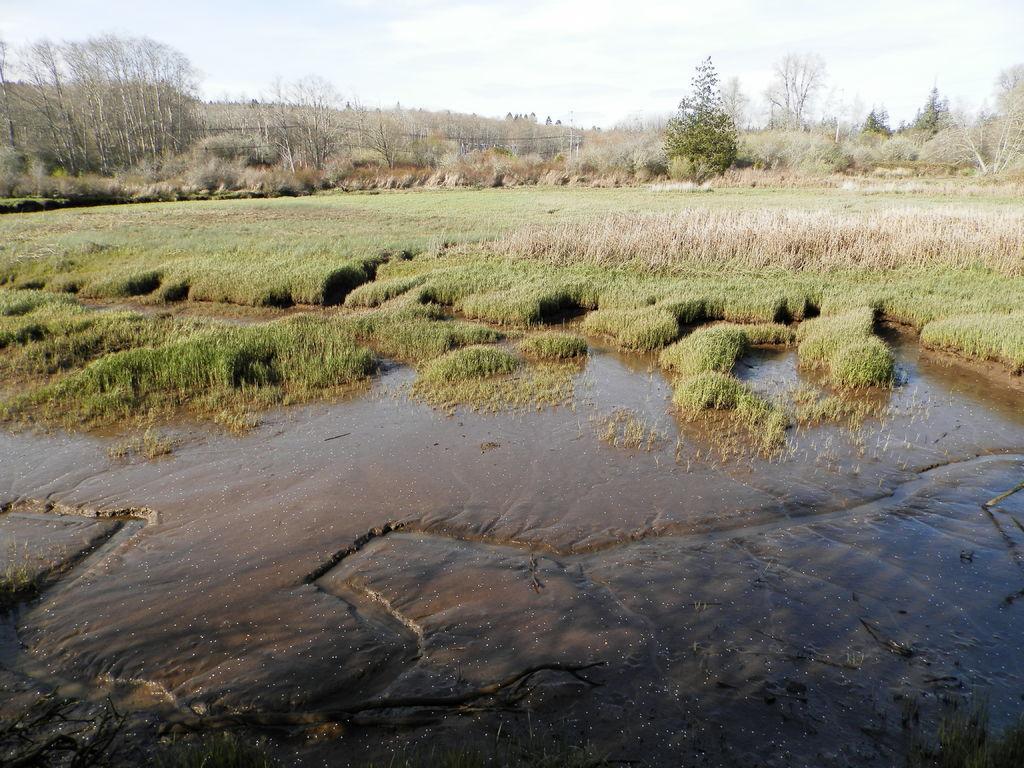In one or two sentences, can you explain what this image depicts? This picture shows trees and we see on the ground and we see water and a cloudy Sky. 